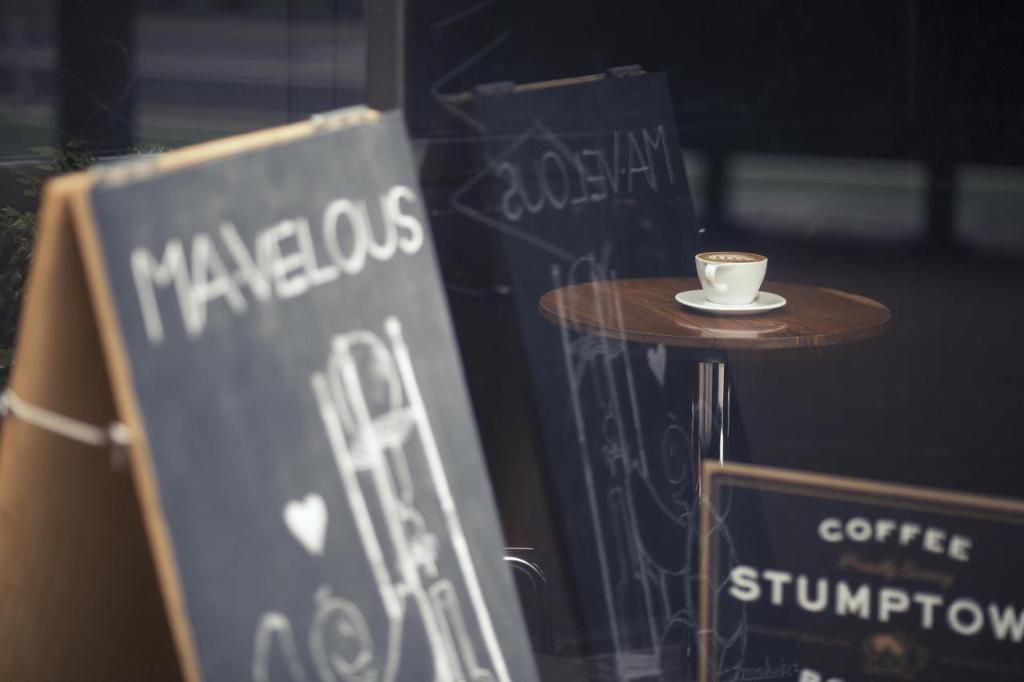Describe this image in one or two sentences. In this picture we can see a cup on the table. And this is the board. 